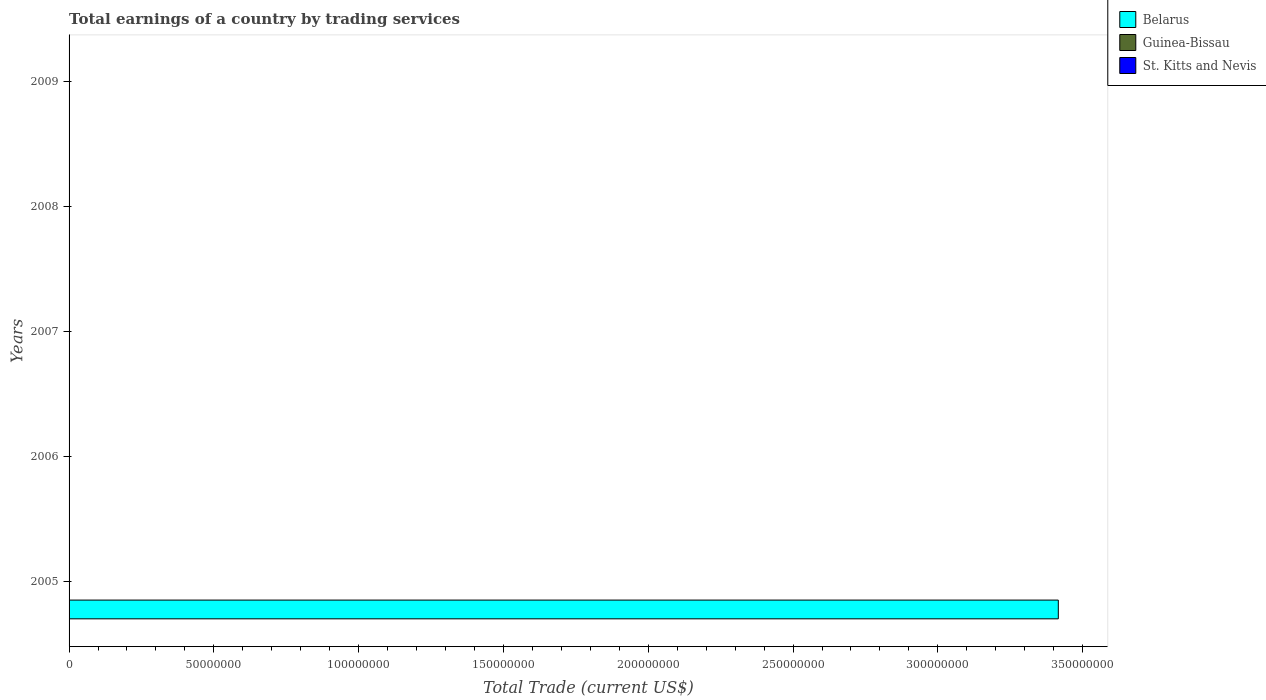How many bars are there on the 5th tick from the top?
Your answer should be compact. 1. What is the label of the 3rd group of bars from the top?
Offer a very short reply. 2007. In how many cases, is the number of bars for a given year not equal to the number of legend labels?
Give a very brief answer. 5. Across all years, what is the maximum total earnings in Belarus?
Provide a short and direct response. 3.42e+08. Across all years, what is the minimum total earnings in Belarus?
Offer a very short reply. 0. What is the total total earnings in Belarus in the graph?
Make the answer very short. 3.42e+08. What is the difference between the total earnings in Belarus in 2006 and the total earnings in St. Kitts and Nevis in 2007?
Make the answer very short. 0. In how many years, is the total earnings in Guinea-Bissau greater than 110000000 US$?
Provide a short and direct response. 0. In how many years, is the total earnings in Guinea-Bissau greater than the average total earnings in Guinea-Bissau taken over all years?
Keep it short and to the point. 0. How many bars are there?
Provide a succinct answer. 1. Are all the bars in the graph horizontal?
Ensure brevity in your answer.  Yes. Does the graph contain any zero values?
Your response must be concise. Yes. What is the title of the graph?
Offer a terse response. Total earnings of a country by trading services. Does "Kazakhstan" appear as one of the legend labels in the graph?
Make the answer very short. No. What is the label or title of the X-axis?
Provide a succinct answer. Total Trade (current US$). What is the Total Trade (current US$) of Belarus in 2005?
Your response must be concise. 3.42e+08. What is the Total Trade (current US$) of Guinea-Bissau in 2005?
Your answer should be very brief. 0. What is the Total Trade (current US$) of Guinea-Bissau in 2008?
Provide a succinct answer. 0. What is the Total Trade (current US$) in Guinea-Bissau in 2009?
Provide a succinct answer. 0. What is the Total Trade (current US$) of St. Kitts and Nevis in 2009?
Your response must be concise. 0. Across all years, what is the maximum Total Trade (current US$) in Belarus?
Your answer should be compact. 3.42e+08. Across all years, what is the minimum Total Trade (current US$) of Belarus?
Keep it short and to the point. 0. What is the total Total Trade (current US$) in Belarus in the graph?
Your response must be concise. 3.42e+08. What is the average Total Trade (current US$) in Belarus per year?
Your answer should be very brief. 6.83e+07. What is the average Total Trade (current US$) in Guinea-Bissau per year?
Keep it short and to the point. 0. What is the difference between the highest and the lowest Total Trade (current US$) of Belarus?
Ensure brevity in your answer.  3.42e+08. 